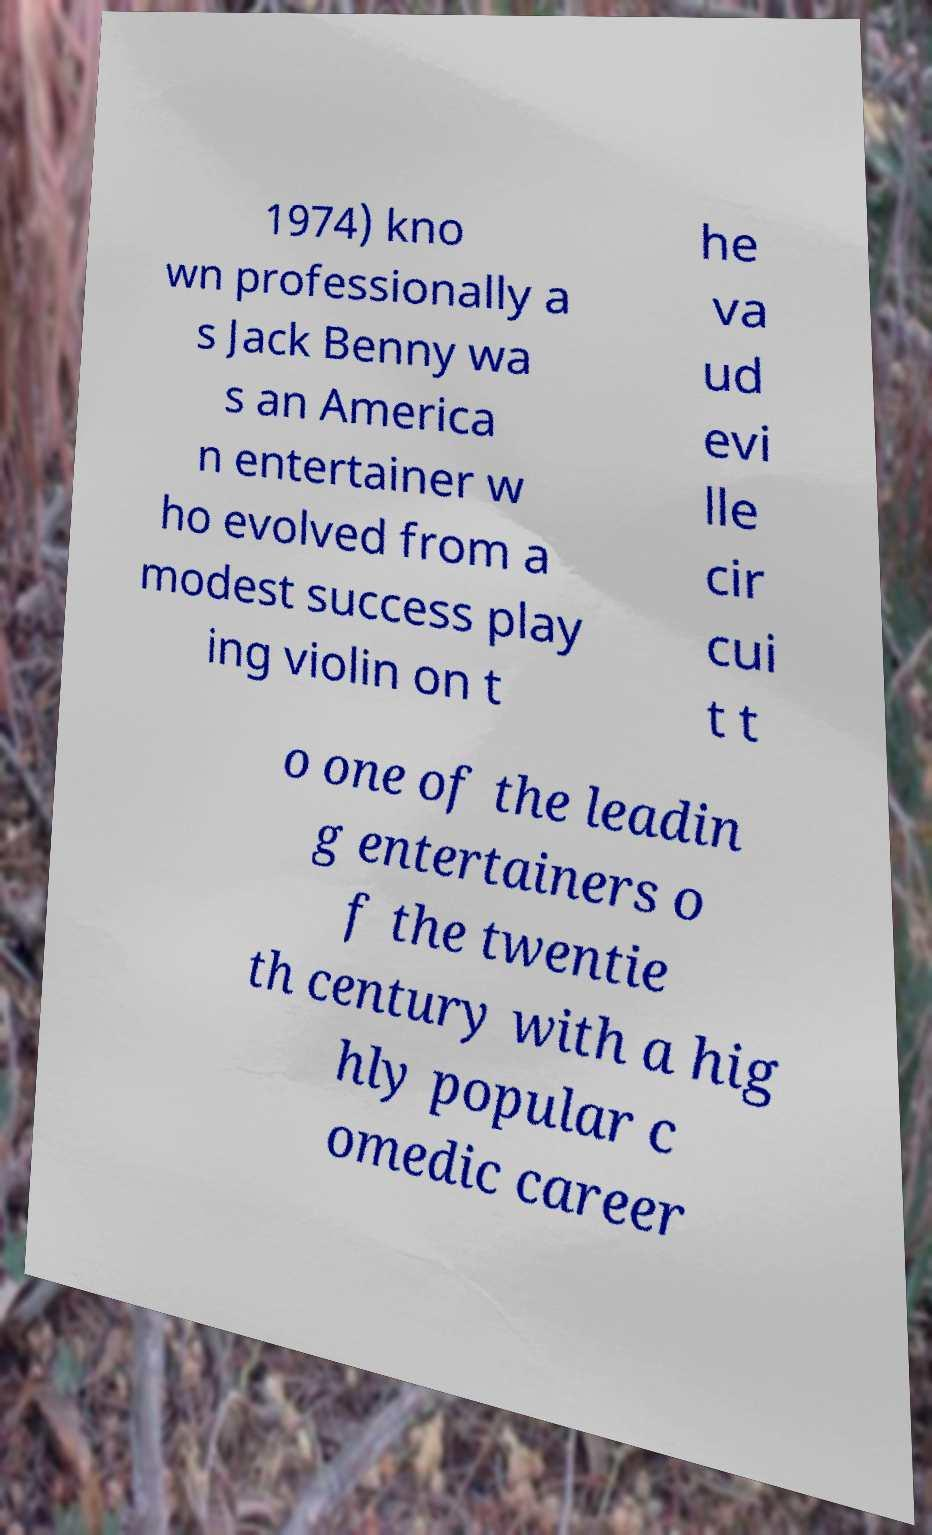Can you accurately transcribe the text from the provided image for me? 1974) kno wn professionally a s Jack Benny wa s an America n entertainer w ho evolved from a modest success play ing violin on t he va ud evi lle cir cui t t o one of the leadin g entertainers o f the twentie th century with a hig hly popular c omedic career 